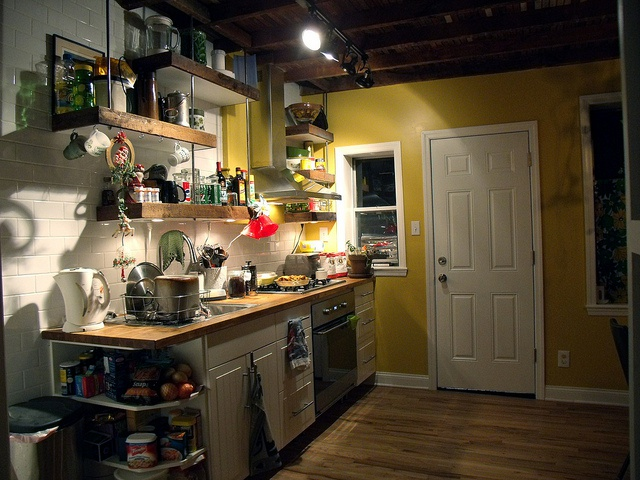Describe the objects in this image and their specific colors. I can see oven in black, gray, and darkgreen tones, chair in black tones, sink in black, gray, and tan tones, bottle in black and darkgreen tones, and bottle in black, darkgreen, and gray tones in this image. 